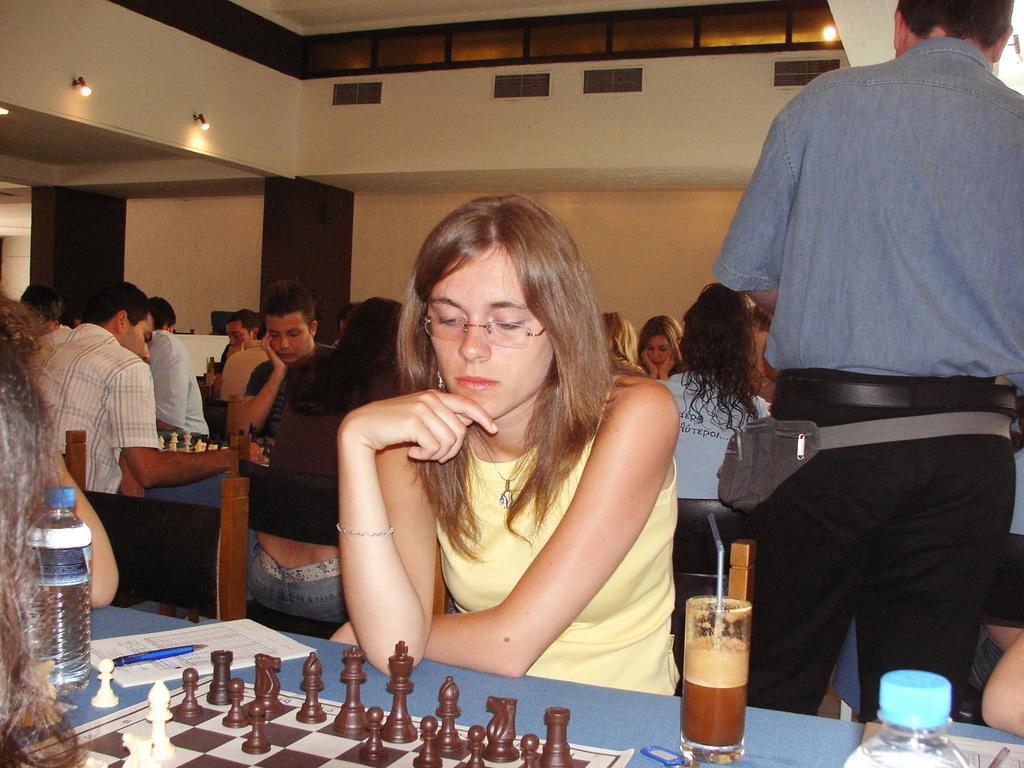Please provide a concise description of this image. There are group of people sitting on the chairs. Here we can see tables. On the table there are chess boards, bottles, paper, pen, and a glass with drink. In the background we can see wall, boards, and lights. 